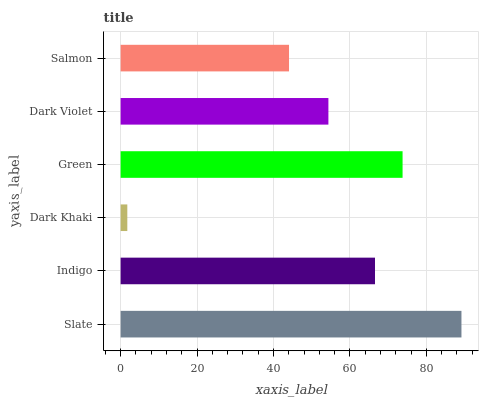Is Dark Khaki the minimum?
Answer yes or no. Yes. Is Slate the maximum?
Answer yes or no. Yes. Is Indigo the minimum?
Answer yes or no. No. Is Indigo the maximum?
Answer yes or no. No. Is Slate greater than Indigo?
Answer yes or no. Yes. Is Indigo less than Slate?
Answer yes or no. Yes. Is Indigo greater than Slate?
Answer yes or no. No. Is Slate less than Indigo?
Answer yes or no. No. Is Indigo the high median?
Answer yes or no. Yes. Is Dark Violet the low median?
Answer yes or no. Yes. Is Dark Violet the high median?
Answer yes or no. No. Is Slate the low median?
Answer yes or no. No. 